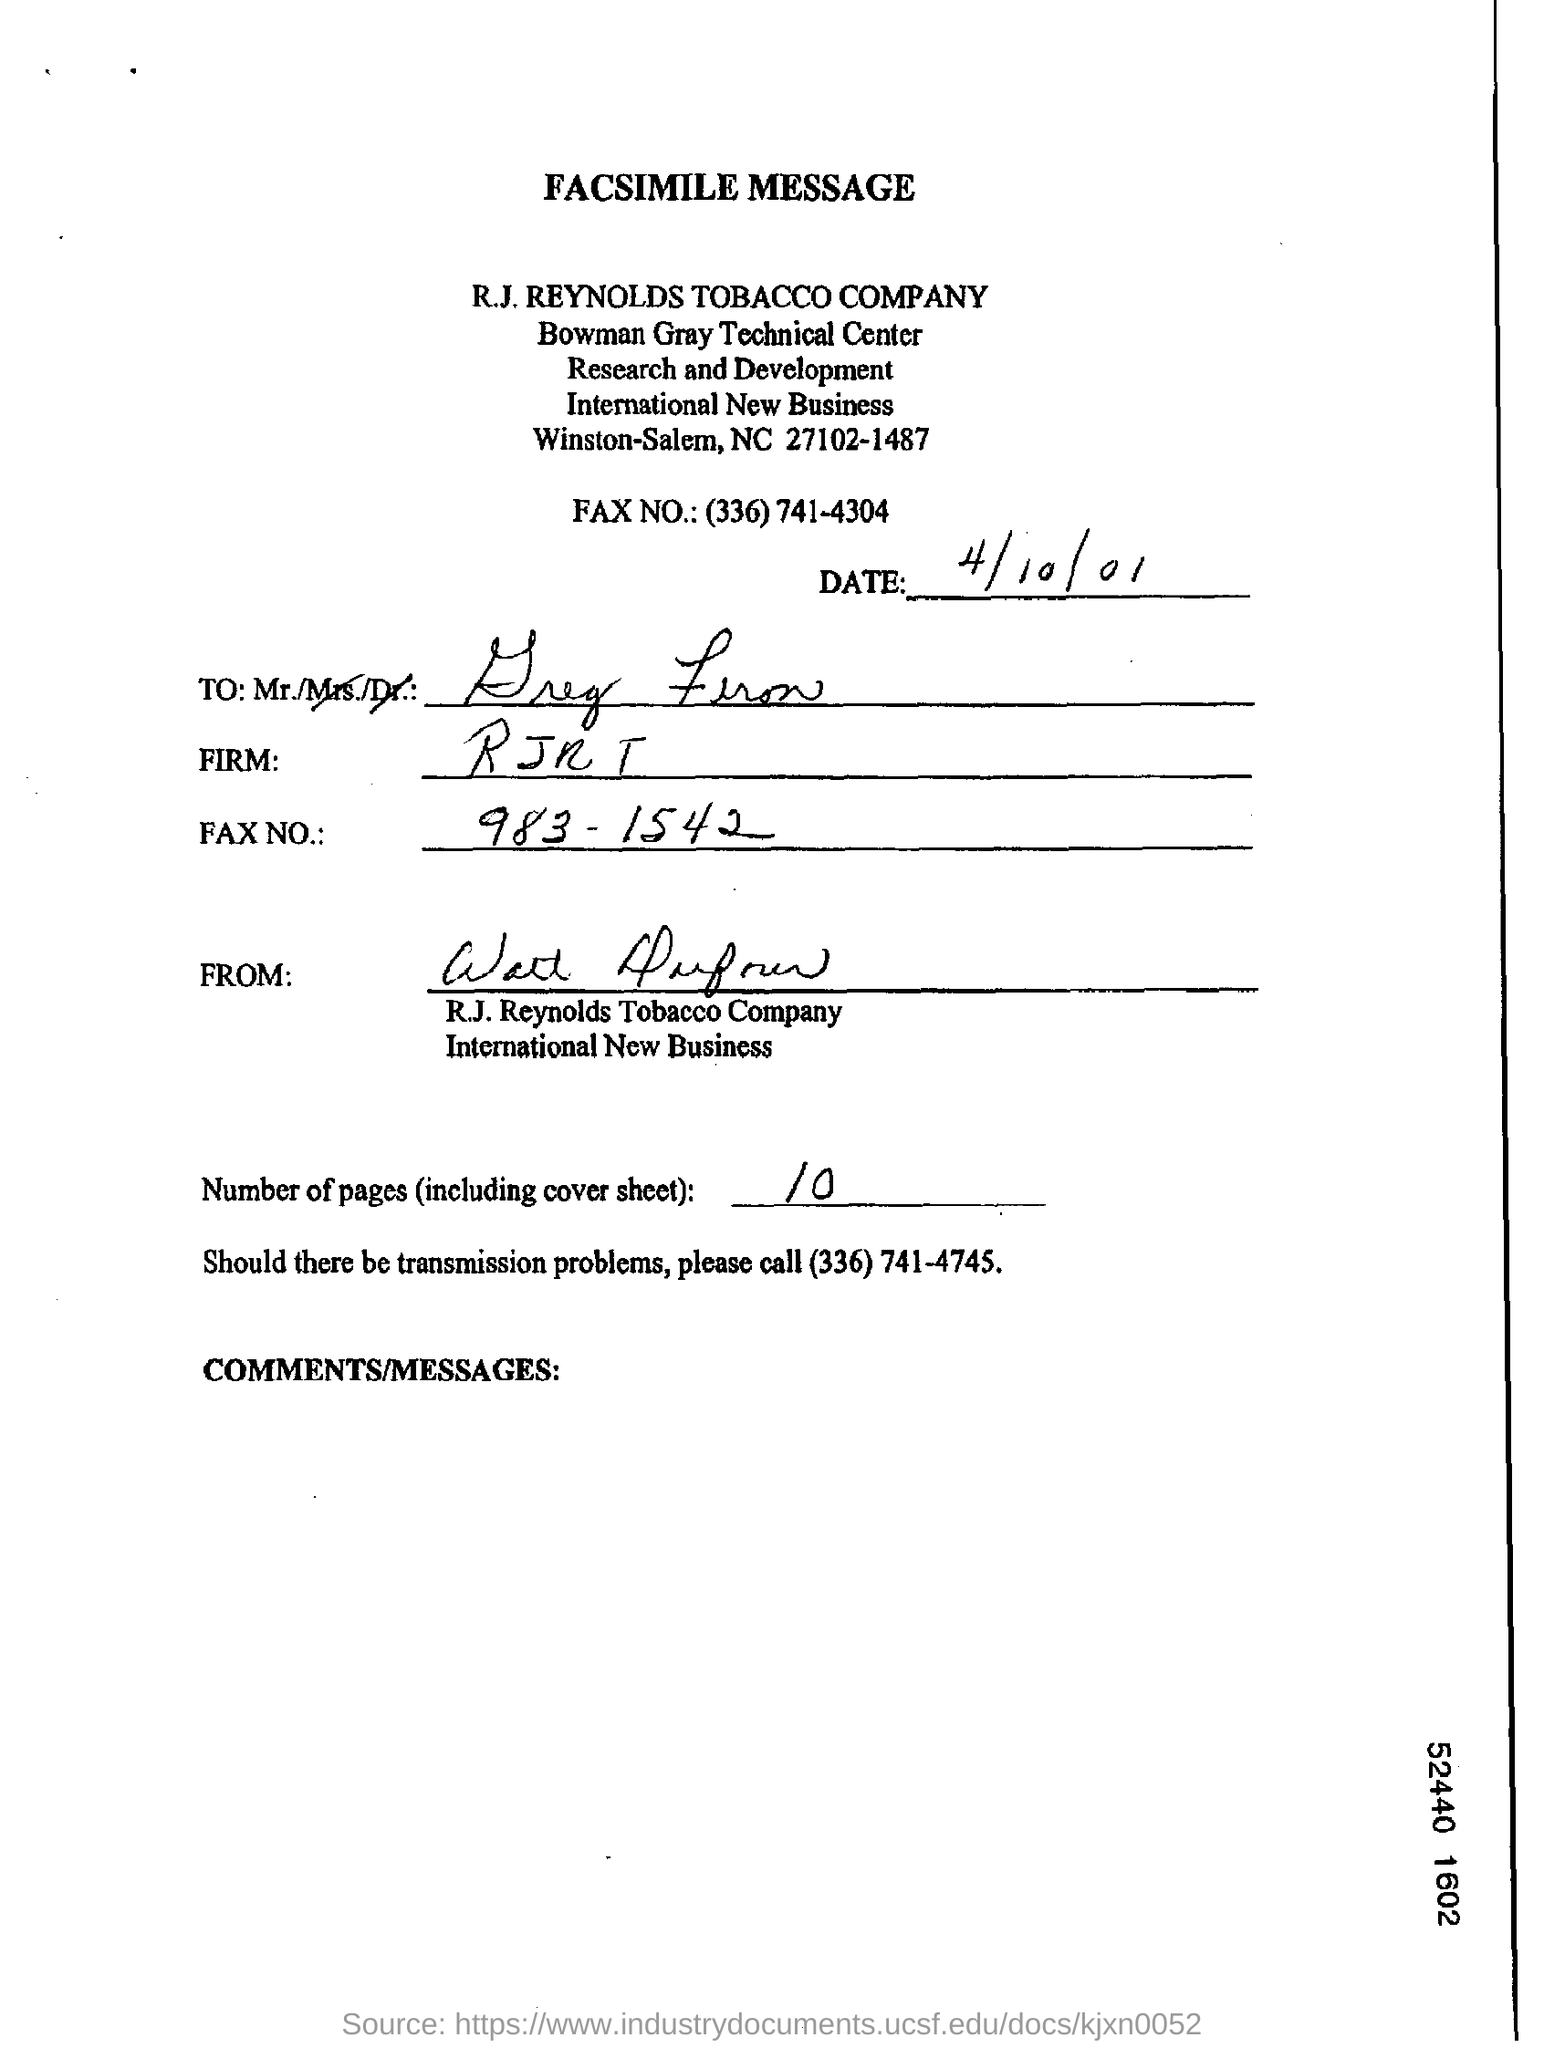Specify some key components in this picture. The number of pages, including the cover sheet, is 10. The date on the document is April 10, 2001. 